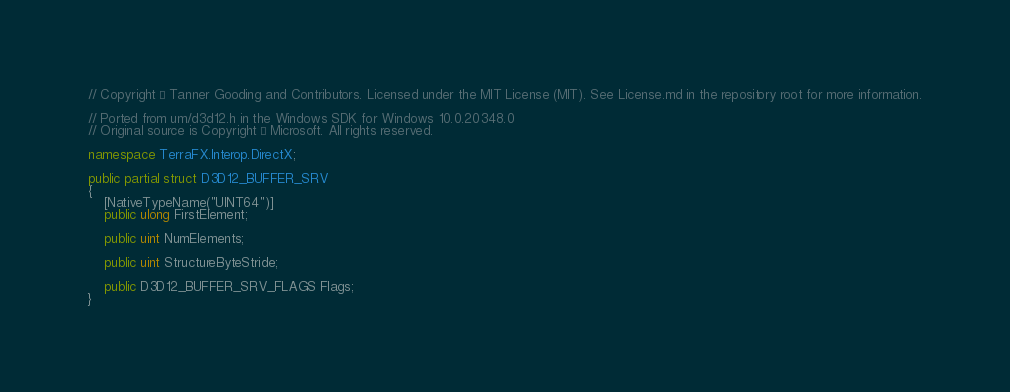Convert code to text. <code><loc_0><loc_0><loc_500><loc_500><_C#_>// Copyright © Tanner Gooding and Contributors. Licensed under the MIT License (MIT). See License.md in the repository root for more information.

// Ported from um/d3d12.h in the Windows SDK for Windows 10.0.20348.0
// Original source is Copyright © Microsoft. All rights reserved.

namespace TerraFX.Interop.DirectX;

public partial struct D3D12_BUFFER_SRV
{
    [NativeTypeName("UINT64")]
    public ulong FirstElement;

    public uint NumElements;

    public uint StructureByteStride;

    public D3D12_BUFFER_SRV_FLAGS Flags;
}
</code> 